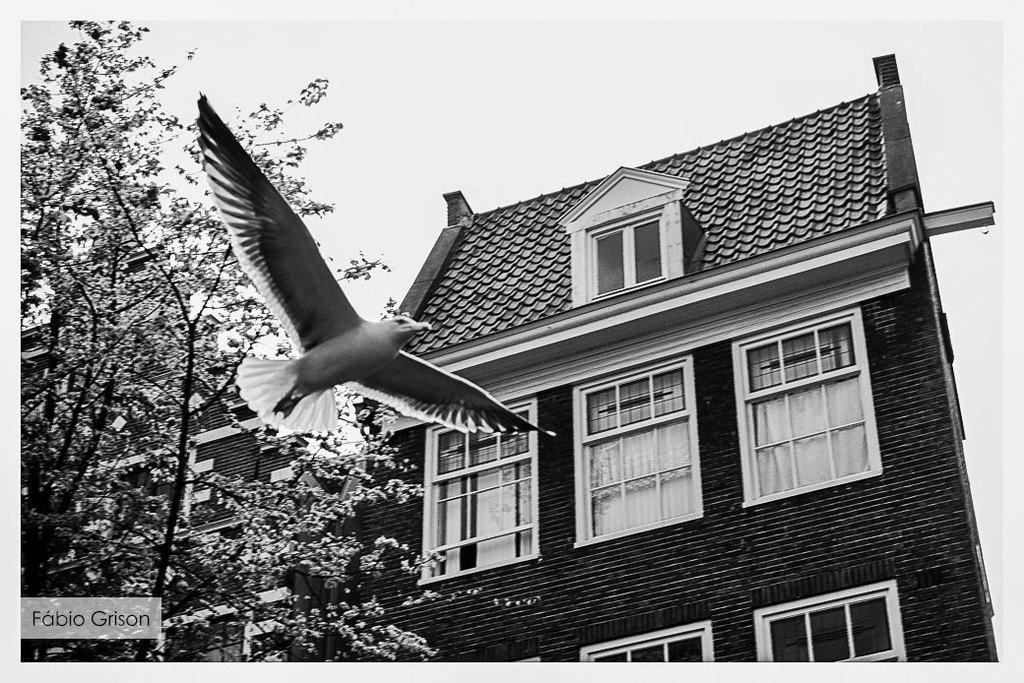What is the main subject of the image? The main subject of the image is a bird flying. What structure can be seen on the right side of the image? There is a house on the right side of the image. What type of vegetation is on the left side of the image? There is a tree on the left side of the image. What type of distribution is being made by the man in the image? There is no man present in the image, so it is not possible to answer a question about a distribution being made by a man. 